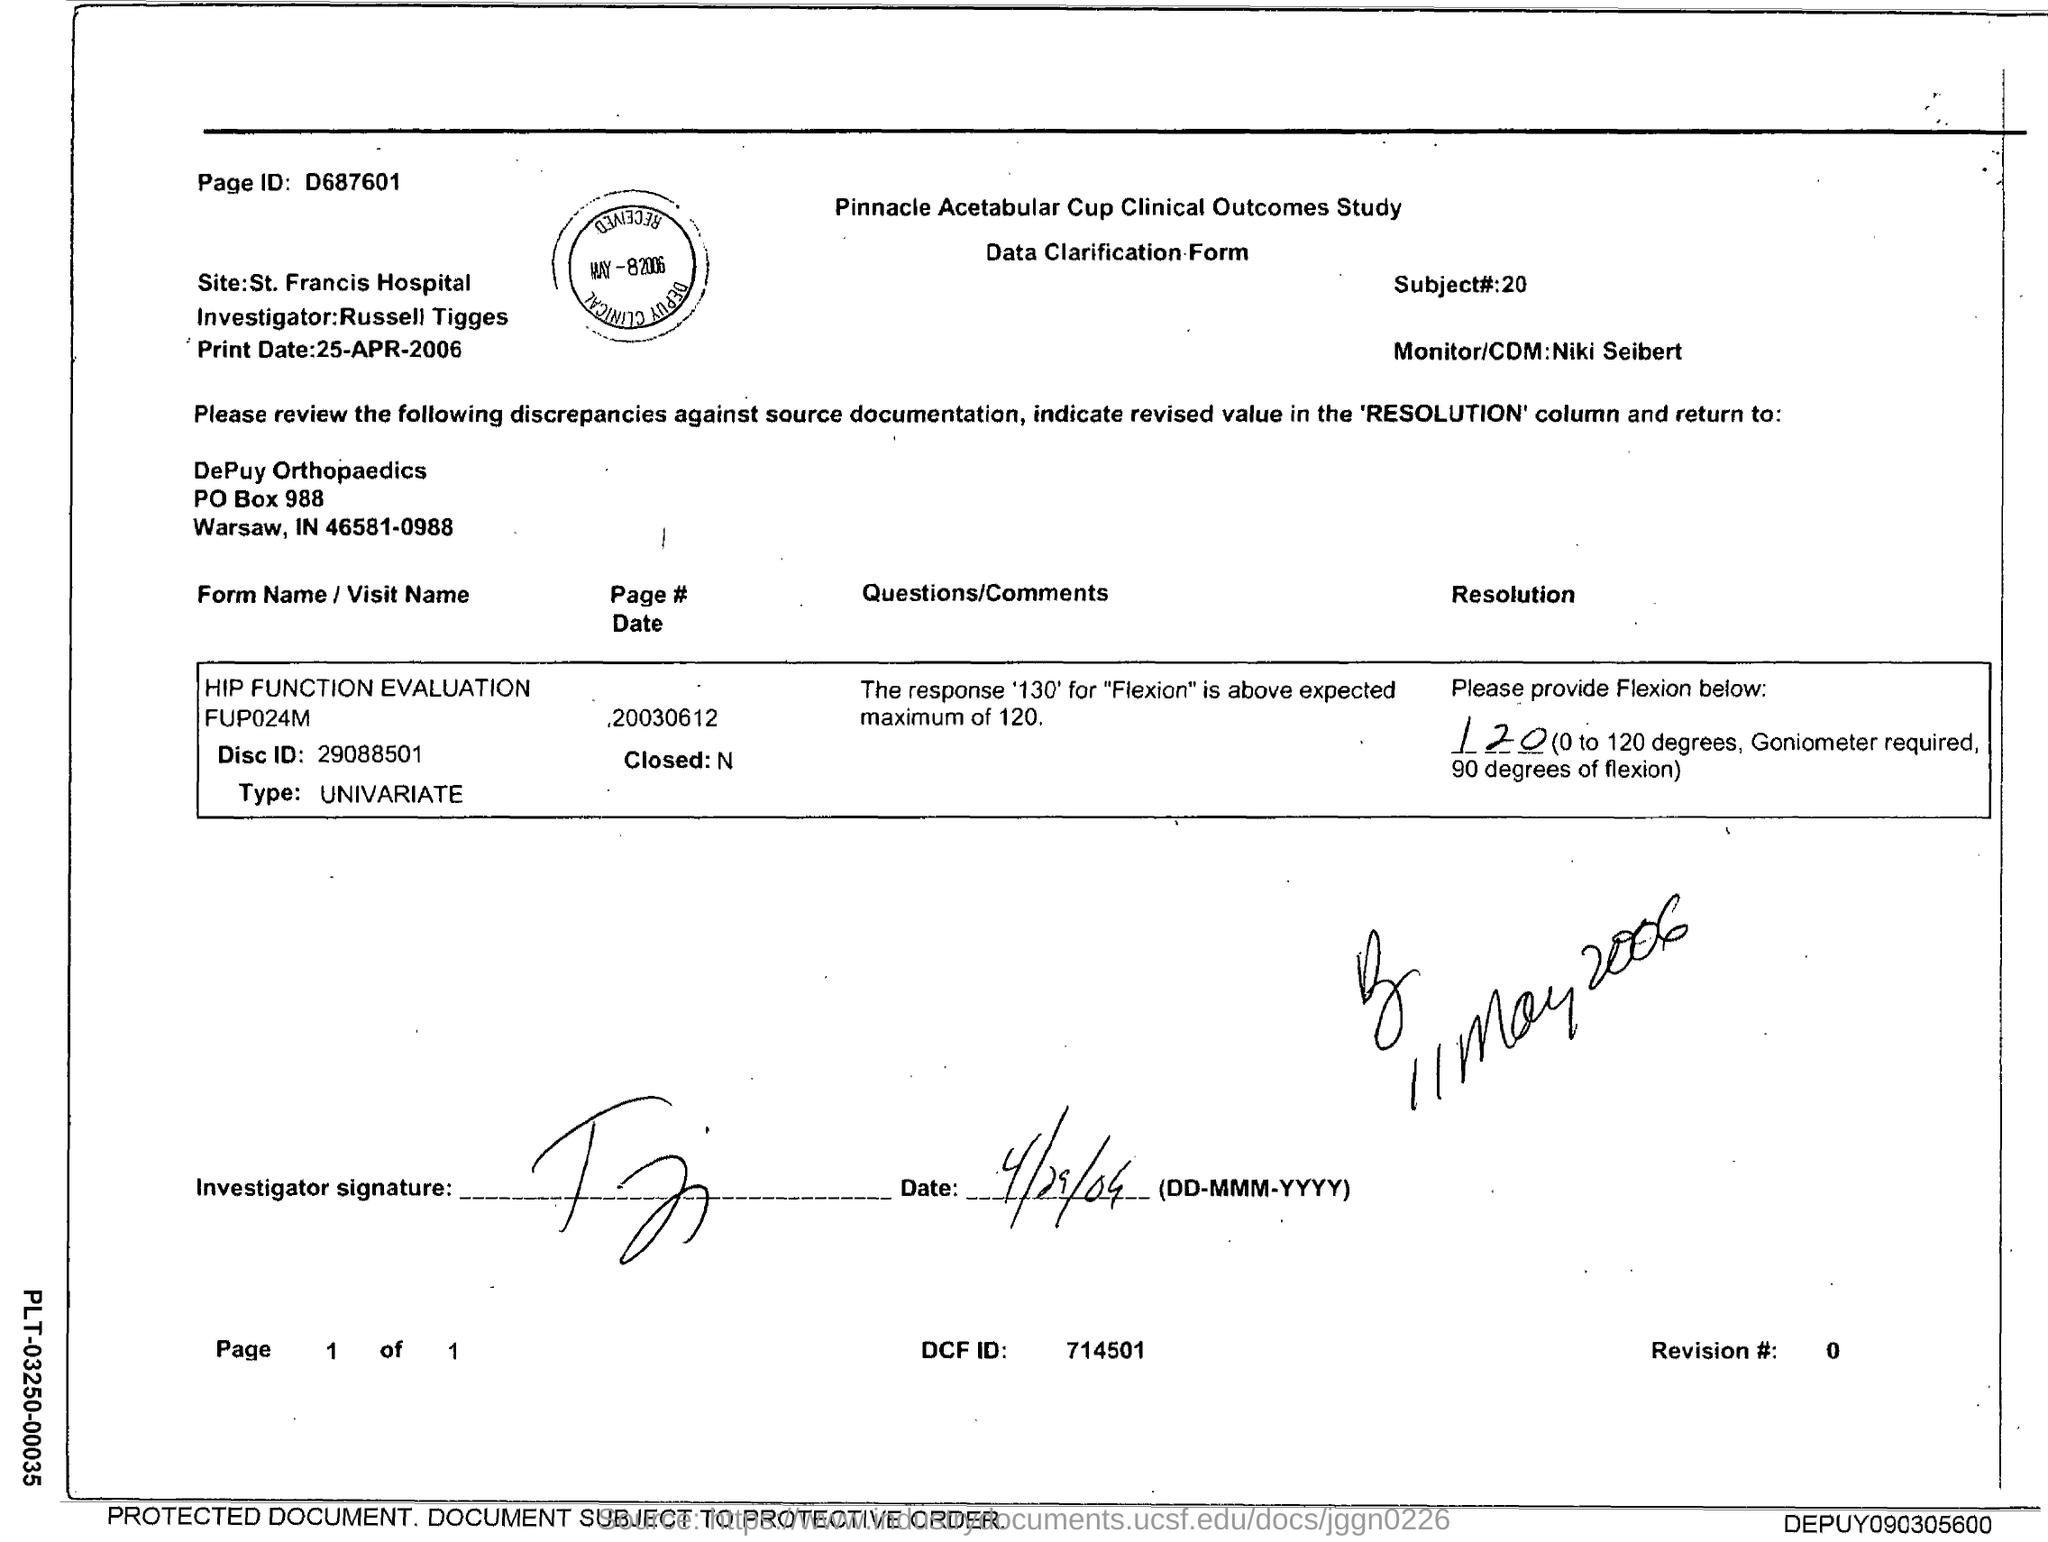Specify some key components in this picture. The investigator's name is Russell Tigges. The PO Box number mentioned in the document is 988. Niki Seibert is the Monitor/CDM. The page identifier in the mentioned document is D687601. The subject number is 20. 